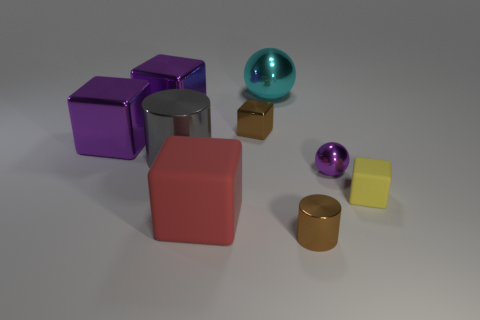Subtract all red cubes. How many cubes are left? 4 Subtract all large red cubes. How many cubes are left? 4 Subtract all cyan blocks. Subtract all brown spheres. How many blocks are left? 5 Add 1 big gray cylinders. How many objects exist? 10 Subtract all balls. How many objects are left? 7 Add 8 big red rubber blocks. How many big red rubber blocks are left? 9 Add 4 big red matte things. How many big red matte things exist? 5 Subtract 0 green cylinders. How many objects are left? 9 Subtract all small things. Subtract all brown objects. How many objects are left? 3 